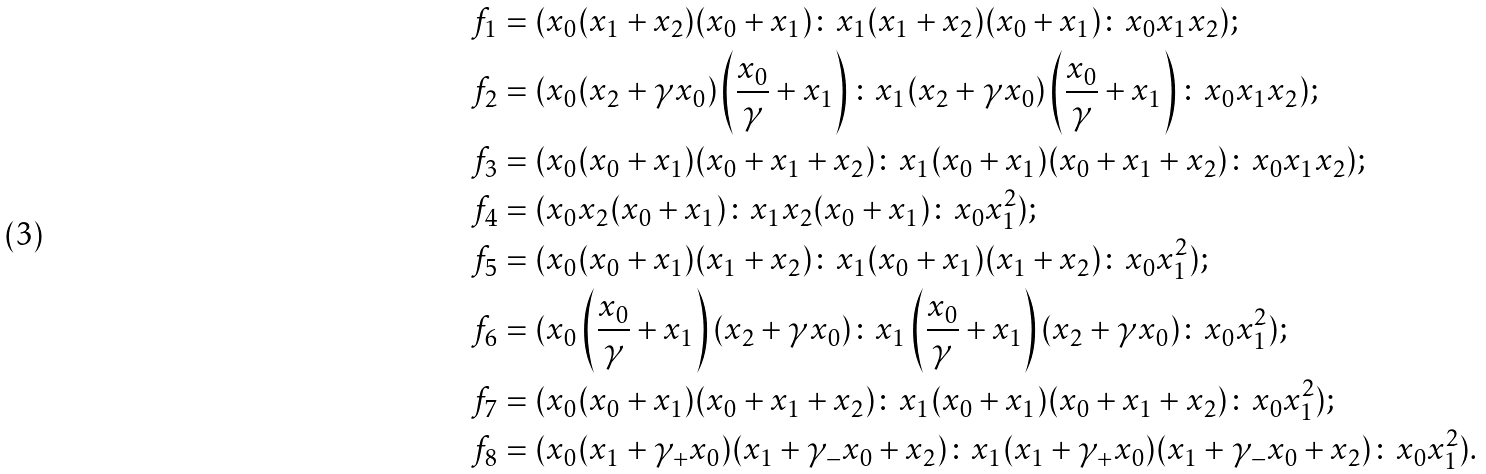Convert formula to latex. <formula><loc_0><loc_0><loc_500><loc_500>& f _ { 1 } = ( x _ { 0 } ( x _ { 1 } + x _ { 2 } ) ( x _ { 0 } + x _ { 1 } ) \colon x _ { 1 } ( x _ { 1 } + x _ { 2 } ) ( x _ { 0 } + x _ { 1 } ) \colon x _ { 0 } x _ { 1 } x _ { 2 } ) ; \\ & f _ { 2 } = ( x _ { 0 } ( x _ { 2 } + \gamma x _ { 0 } ) \left ( \frac { x _ { 0 } } { \gamma } + x _ { 1 } \right ) \colon x _ { 1 } ( x _ { 2 } + \gamma x _ { 0 } ) \left ( \frac { x _ { 0 } } { \gamma } + x _ { 1 } \right ) \colon x _ { 0 } x _ { 1 } x _ { 2 } ) ; \\ & f _ { 3 } = ( x _ { 0 } ( x _ { 0 } + x _ { 1 } ) ( x _ { 0 } + x _ { 1 } + x _ { 2 } ) \colon x _ { 1 } ( x _ { 0 } + x _ { 1 } ) ( x _ { 0 } + x _ { 1 } + x _ { 2 } ) \colon x _ { 0 } x _ { 1 } x _ { 2 } ) ; \\ & f _ { 4 } = ( x _ { 0 } x _ { 2 } ( x _ { 0 } + x _ { 1 } ) \colon x _ { 1 } x _ { 2 } ( x _ { 0 } + x _ { 1 } ) \colon x _ { 0 } x _ { 1 } ^ { 2 } ) ; \\ & f _ { 5 } = ( x _ { 0 } ( x _ { 0 } + x _ { 1 } ) ( x _ { 1 } + x _ { 2 } ) \colon x _ { 1 } ( x _ { 0 } + x _ { 1 } ) ( x _ { 1 } + x _ { 2 } ) \colon x _ { 0 } x _ { 1 } ^ { 2 } ) ; \\ & f _ { 6 } = ( x _ { 0 } \left ( \frac { x _ { 0 } } { \gamma } + x _ { 1 } \right ) ( x _ { 2 } + \gamma x _ { 0 } ) \colon x _ { 1 } \left ( \frac { x _ { 0 } } { \gamma } + x _ { 1 } \right ) ( x _ { 2 } + \gamma x _ { 0 } ) \colon x _ { 0 } x _ { 1 } ^ { 2 } ) ; \\ & f _ { 7 } = ( x _ { 0 } ( x _ { 0 } + x _ { 1 } ) ( x _ { 0 } + x _ { 1 } + x _ { 2 } ) \colon x _ { 1 } ( x _ { 0 } + x _ { 1 } ) ( x _ { 0 } + x _ { 1 } + x _ { 2 } ) \colon x _ { 0 } x _ { 1 } ^ { 2 } ) ; \\ & f _ { 8 } = ( x _ { 0 } ( x _ { 1 } + \gamma _ { + } x _ { 0 } ) ( x _ { 1 } + \gamma _ { - } x _ { 0 } + x _ { 2 } ) \colon x _ { 1 } ( x _ { 1 } + \gamma _ { + } x _ { 0 } ) ( x _ { 1 } + \gamma _ { - } x _ { 0 } + x _ { 2 } ) \colon x _ { 0 } x _ { 1 } ^ { 2 } ) .</formula> 